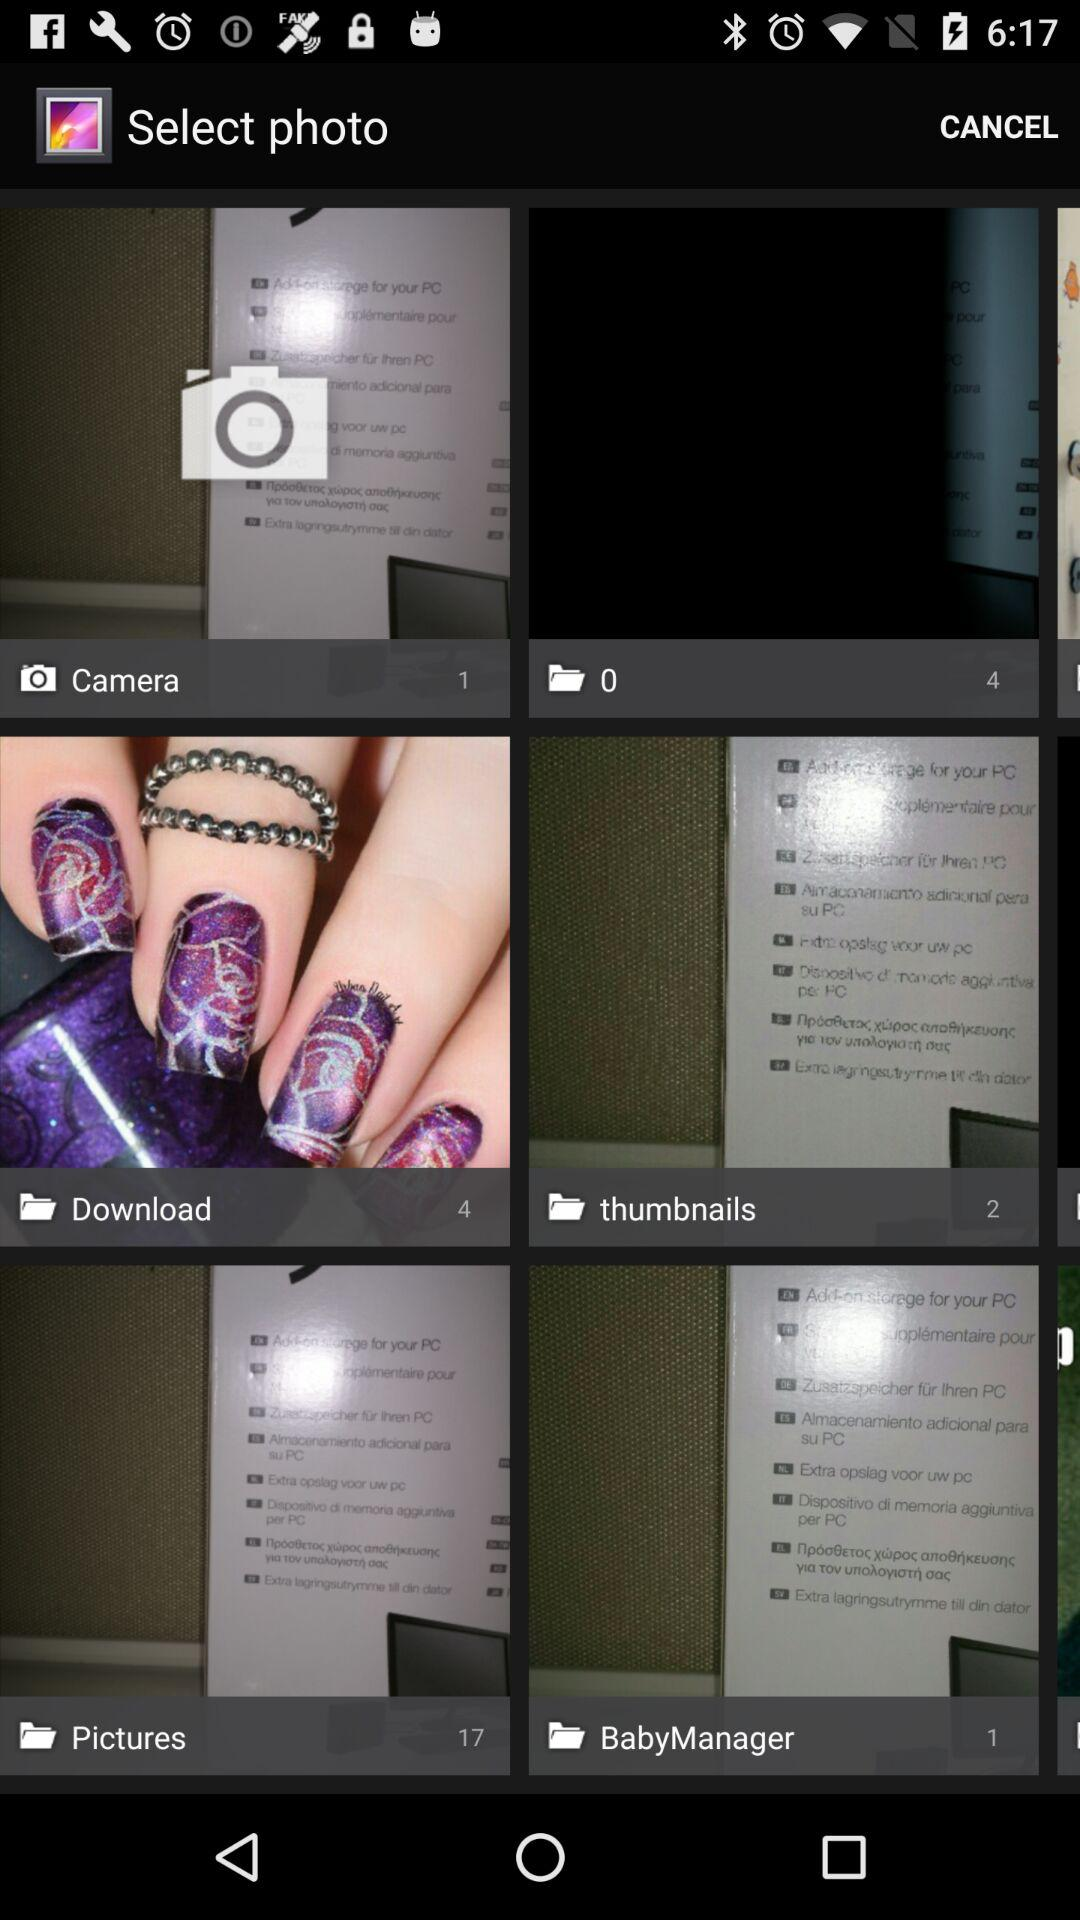How many photos are there in the download folder? There are 4 photos in the download folder. 